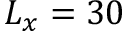Convert formula to latex. <formula><loc_0><loc_0><loc_500><loc_500>L _ { x } = 3 0</formula> 